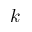Convert formula to latex. <formula><loc_0><loc_0><loc_500><loc_500>k</formula> 